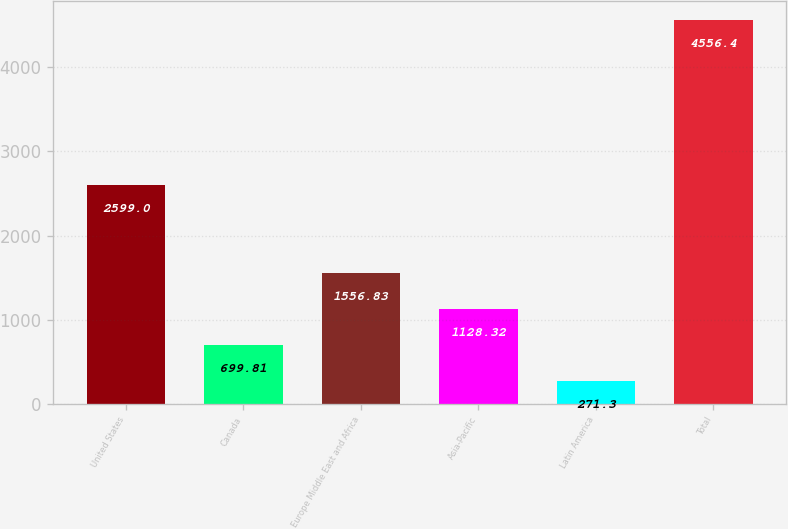Convert chart. <chart><loc_0><loc_0><loc_500><loc_500><bar_chart><fcel>United States<fcel>Canada<fcel>Europe Middle East and Africa<fcel>Asia-Pacific<fcel>Latin America<fcel>Total<nl><fcel>2599<fcel>699.81<fcel>1556.83<fcel>1128.32<fcel>271.3<fcel>4556.4<nl></chart> 